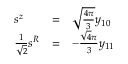Convert formula to latex. <formula><loc_0><loc_0><loc_500><loc_500>\begin{array} { l l l } { { s ^ { z } } } & { = } & { { \sqrt { \frac { 4 \pi } { 3 } } y _ { 1 0 } } } \\ { { { \frac { 1 } { \sqrt { 2 } } } s ^ { R } } } & { = } & { { - { \frac { \sqrt { 4 } \pi } { 3 } } y _ { 1 1 } } } \end{array}</formula> 